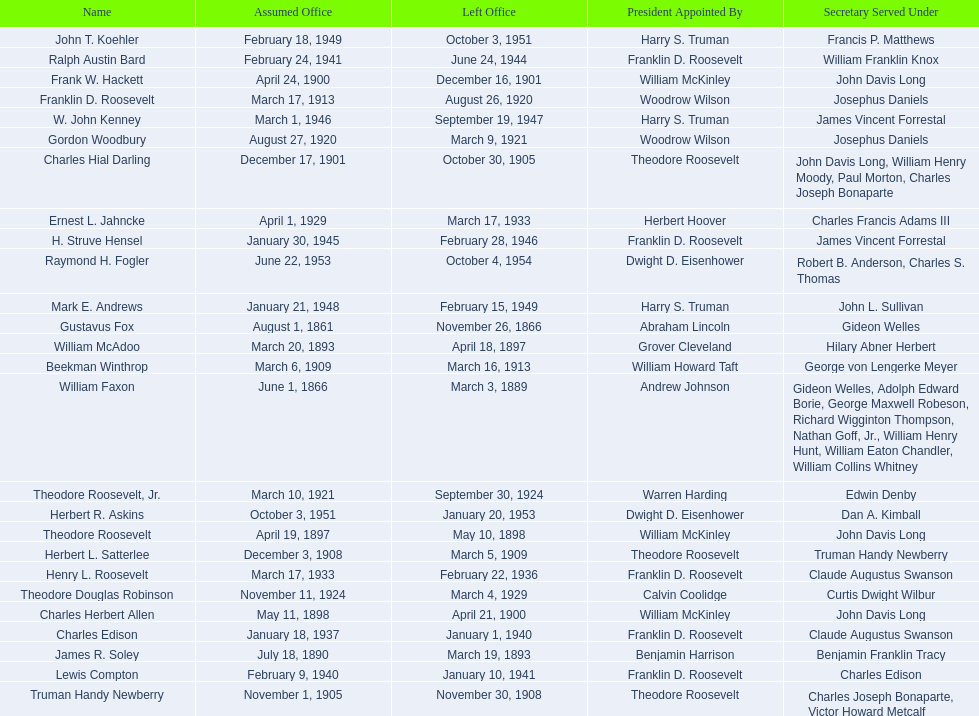Who were all the assistant secretary's of the navy? Gustavus Fox, William Faxon, James R. Soley, William McAdoo, Theodore Roosevelt, Charles Herbert Allen, Frank W. Hackett, Charles Hial Darling, Truman Handy Newberry, Herbert L. Satterlee, Beekman Winthrop, Franklin D. Roosevelt, Gordon Woodbury, Theodore Roosevelt, Jr., Theodore Douglas Robinson, Ernest L. Jahncke, Henry L. Roosevelt, Charles Edison, Lewis Compton, Ralph Austin Bard, H. Struve Hensel, W. John Kenney, Mark E. Andrews, John T. Koehler, Herbert R. Askins, Raymond H. Fogler. What are the various dates they left office in? November 26, 1866, March 3, 1889, March 19, 1893, April 18, 1897, May 10, 1898, April 21, 1900, December 16, 1901, October 30, 1905, November 30, 1908, March 5, 1909, March 16, 1913, August 26, 1920, March 9, 1921, September 30, 1924, March 4, 1929, March 17, 1933, February 22, 1936, January 1, 1940, January 10, 1941, June 24, 1944, February 28, 1946, September 19, 1947, February 15, 1949, October 3, 1951, January 20, 1953, October 4, 1954. Of these dates, which was the date raymond h. fogler left office in? October 4, 1954. 